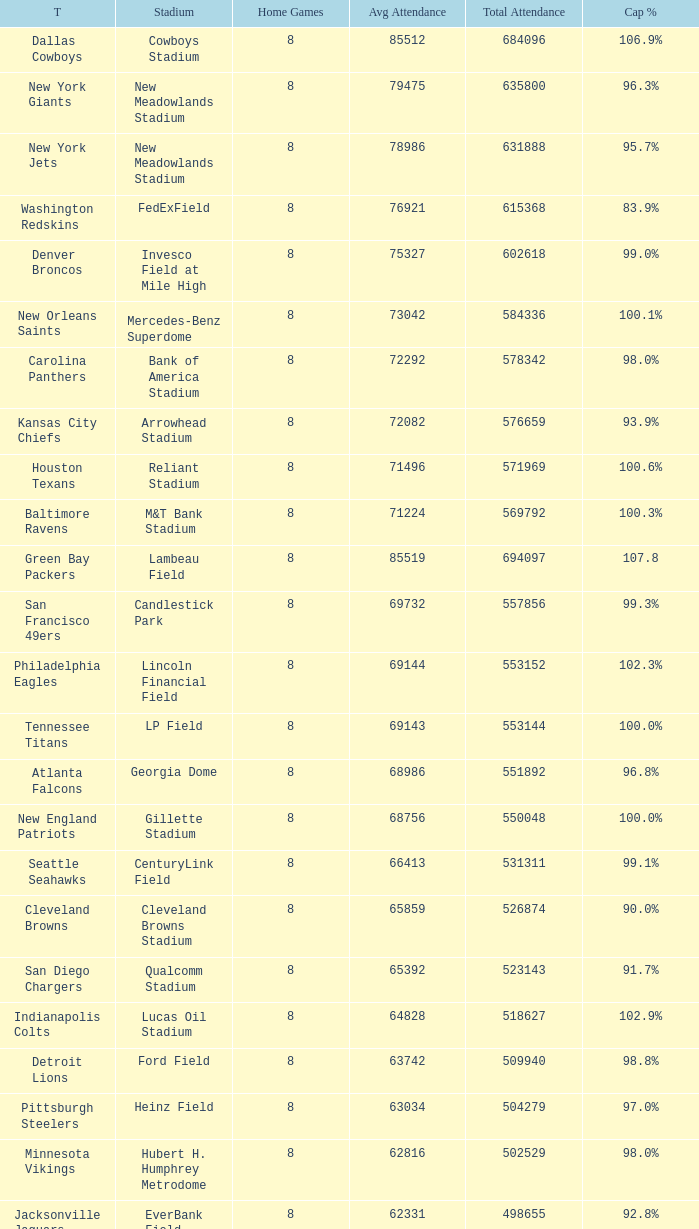How many home games are listed when the average attendance is 79475? 1.0. 